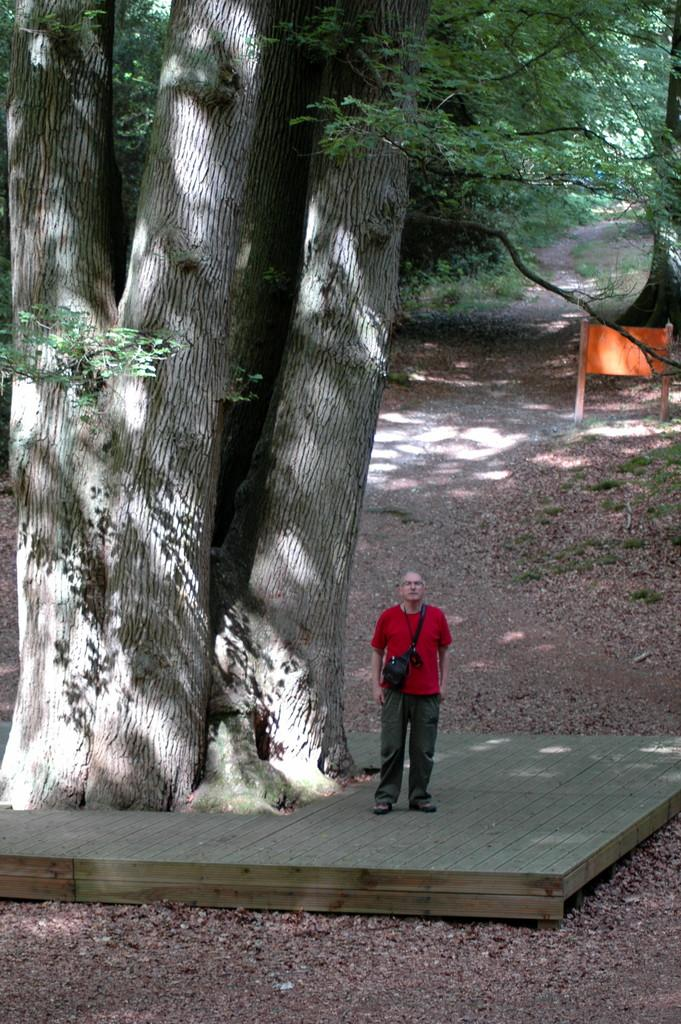What is the main subject of the image? There is a person standing in the image. What type of natural environment is visible in the image? There are trees, grass, and plants in the image. What can be seen hanging or displayed in the image? There is a banner in the image. What is the ground surface like in the image? The ground is visible in the image, and it appears to be covered with grass. Where is the mailbox located in the image? There is no mailbox present in the image. How many chickens can be seen in the image? There are no chickens present in the image. 